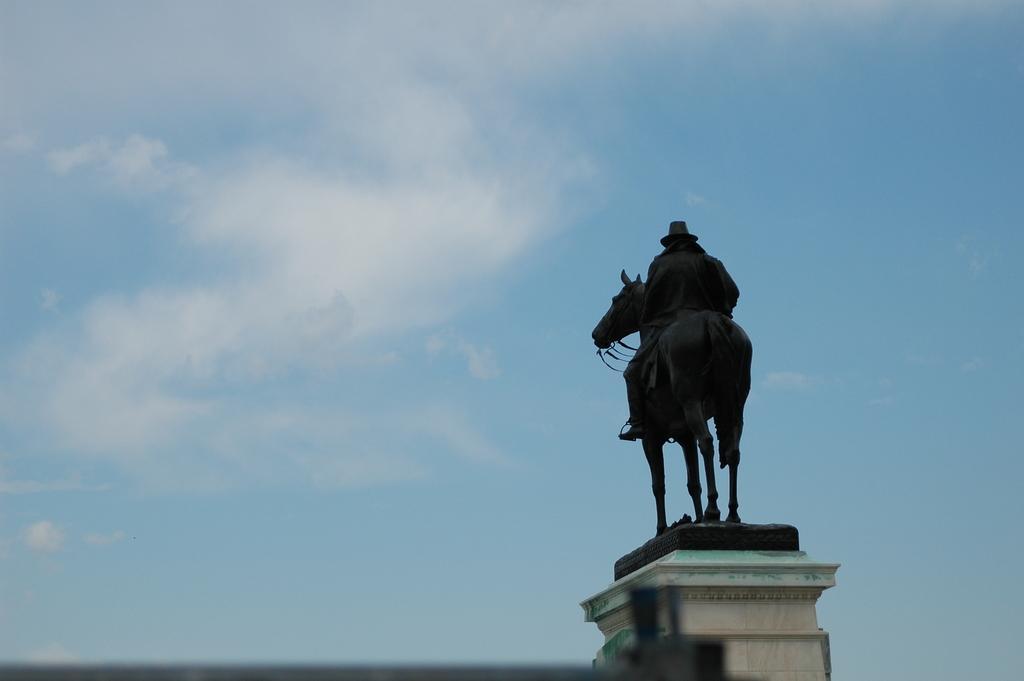Could you give a brief overview of what you see in this image? In this image there is a statue of a man on a horse. There is a cloud in the background. 